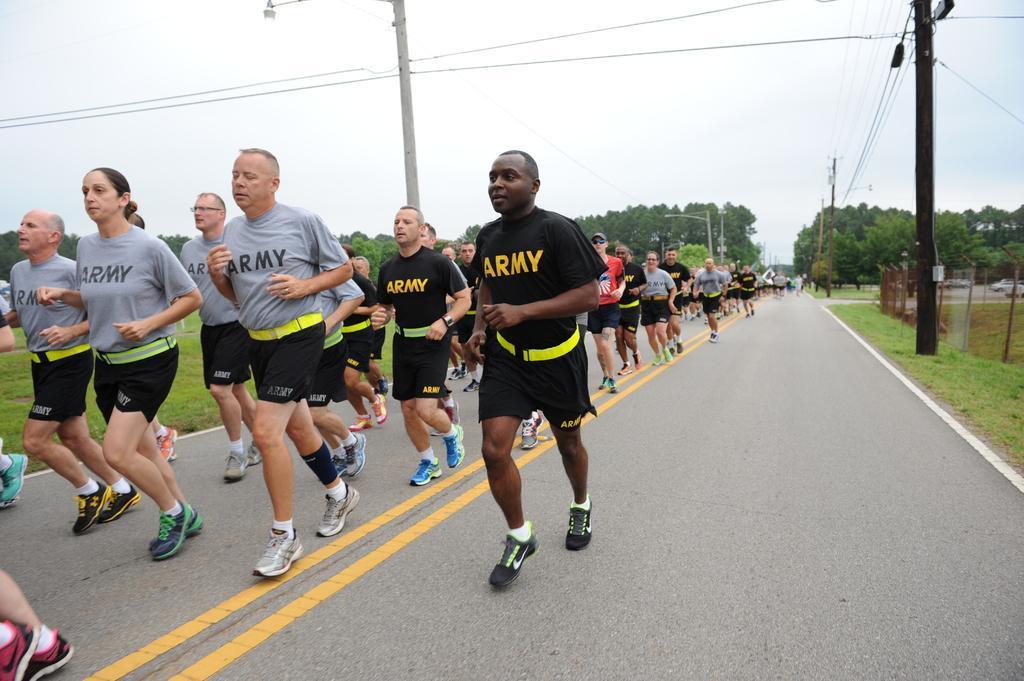Can you describe this image briefly? In this image there are so many people running on the road, on the left and right side of the road there are a few utility poles connected with cables and there is a net fence on the surface of the grass. In the background there are trees and the sky. 